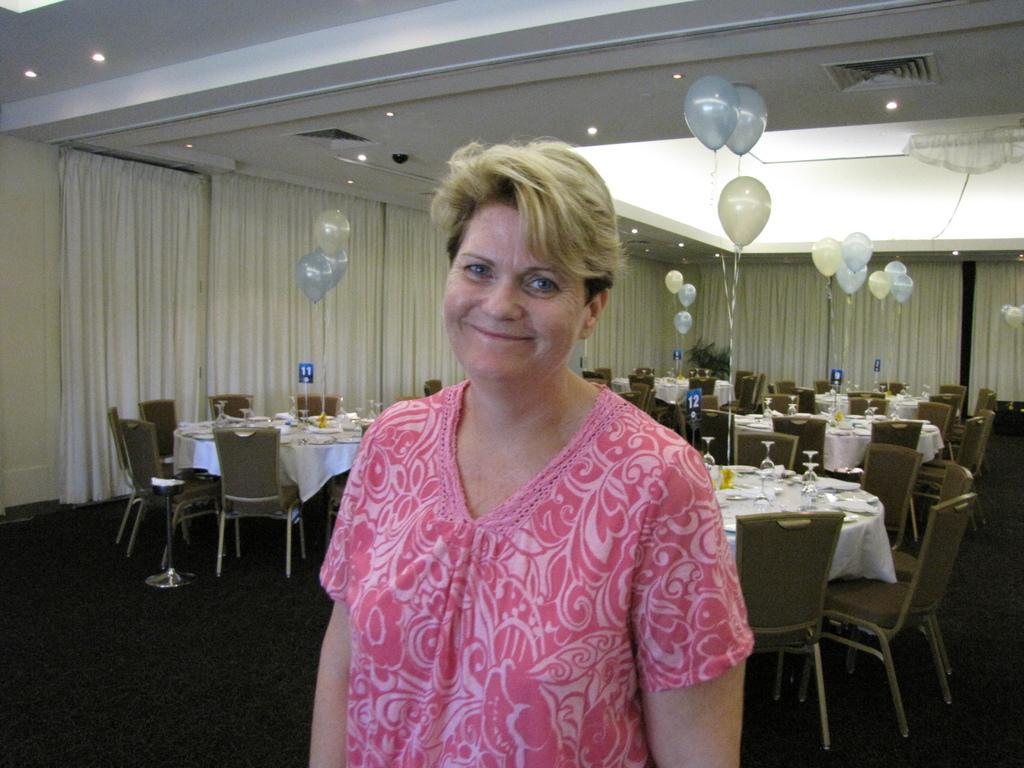How would you summarize this image in a sentence or two? It is big room where a woman is standing and wearing a pink dress, behind her there are number of tables and chairs with so many glasses and plates on it and the balloons are tied to the tables behind her and left corner of the picture there are curtains in white colour. 